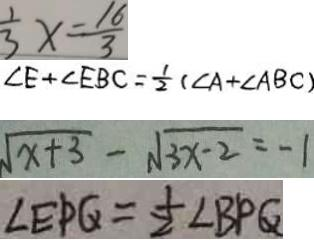Convert formula to latex. <formula><loc_0><loc_0><loc_500><loc_500>\frac { 1 } { 3 } x = \frac { 1 6 } { 3 } 
 \angle E + \angle E B C = \frac { 1 } { 2 } ( \angle A + \angle A B C ) 
 \sqrt { x + 3 } - \sqrt { 3 x - 2 } = - 1 
 \angle E P Q = \frac { 1 } { 2 } \angle B P Q</formula> 